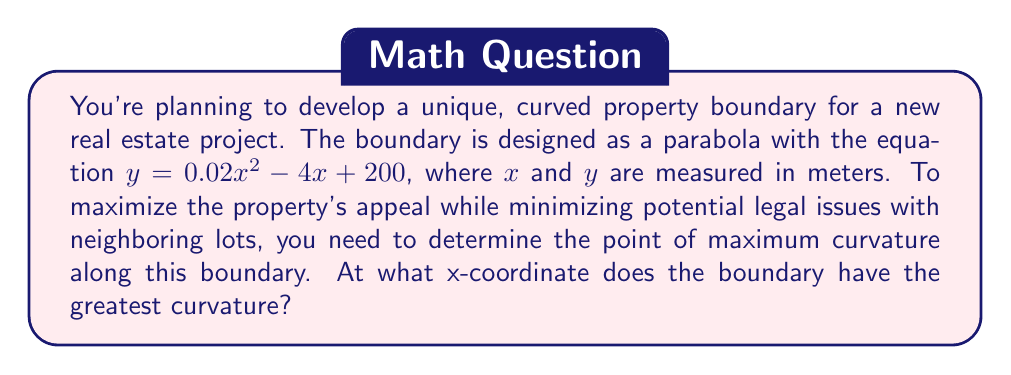Could you help me with this problem? To solve this problem, we'll follow these steps:

1) The curvature of a curve $y = f(x)$ at any point is given by the formula:

   $$\kappa = \frac{|f''(x)|}{(1 + [f'(x)]^2)^{3/2}}$$

2) For our parabola $y = 0.02x^2 - 4x + 200$, we need to find $f'(x)$ and $f''(x)$:

   $f'(x) = 0.04x - 4$
   $f''(x) = 0.04$

3) Substituting these into the curvature formula:

   $$\kappa = \frac{|0.04|}{(1 + [0.04x - 4]^2)^{3/2}}$$

4) To find the maximum curvature, we need to find where the denominator is at its minimum, as the numerator is constant.

5) The denominator will be at its minimum when $[0.04x - 4]^2$ is at its minimum, which occurs when $0.04x - 4 = 0$.

6) Solving this equation:

   $0.04x - 4 = 0$
   $0.04x = 4$
   $x = 100$

7) Therefore, the curvature is greatest when $x = 100$ meters.

[asy]
import graph;
size(200,200);
real f(real x) {return 0.02*x^2 - 4*x + 200;}
draw(graph(f,0,200),blue);
dot((100,f(100)),red);
label("Max curvature",(100,f(100)),N);
xaxis("x (meters)",0,200,Arrow);
yaxis("y (meters)",0,200,Arrow);
[/asy]
Answer: The boundary has the greatest curvature at $x = 100$ meters. 